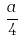Convert formula to latex. <formula><loc_0><loc_0><loc_500><loc_500>\frac { a } { 4 }</formula> 